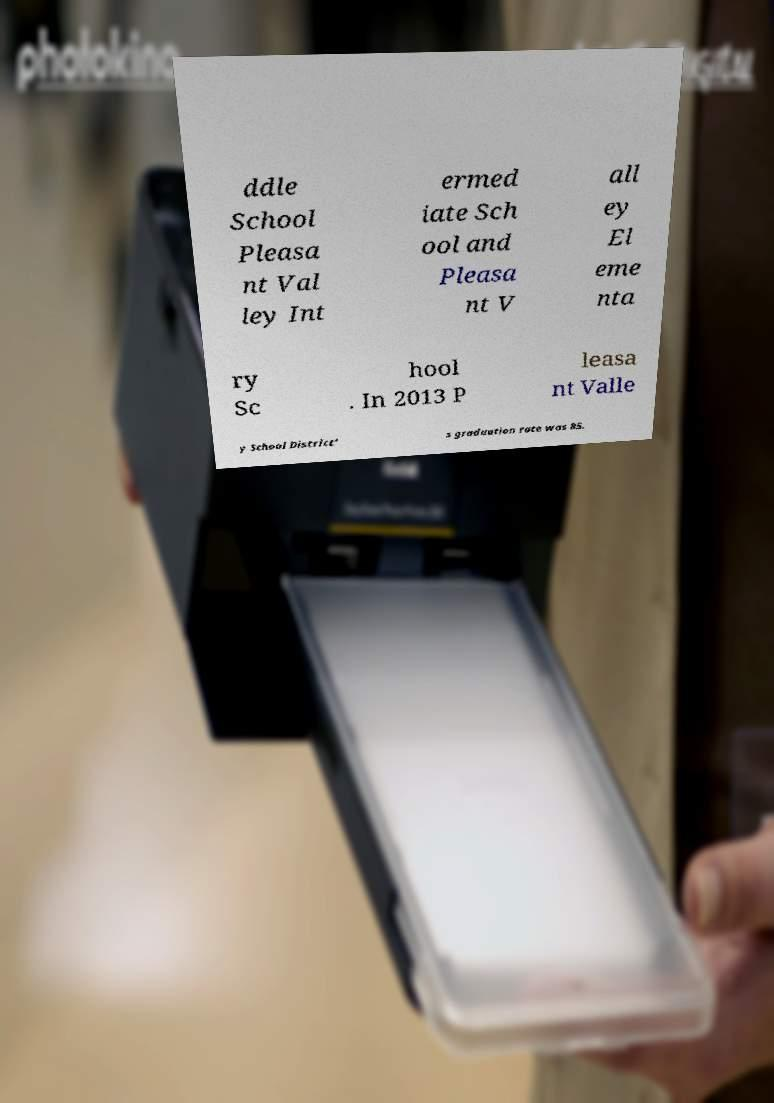Could you assist in decoding the text presented in this image and type it out clearly? ddle School Pleasa nt Val ley Int ermed iate Sch ool and Pleasa nt V all ey El eme nta ry Sc hool . In 2013 P leasa nt Valle y School District' s graduation rate was 85. 